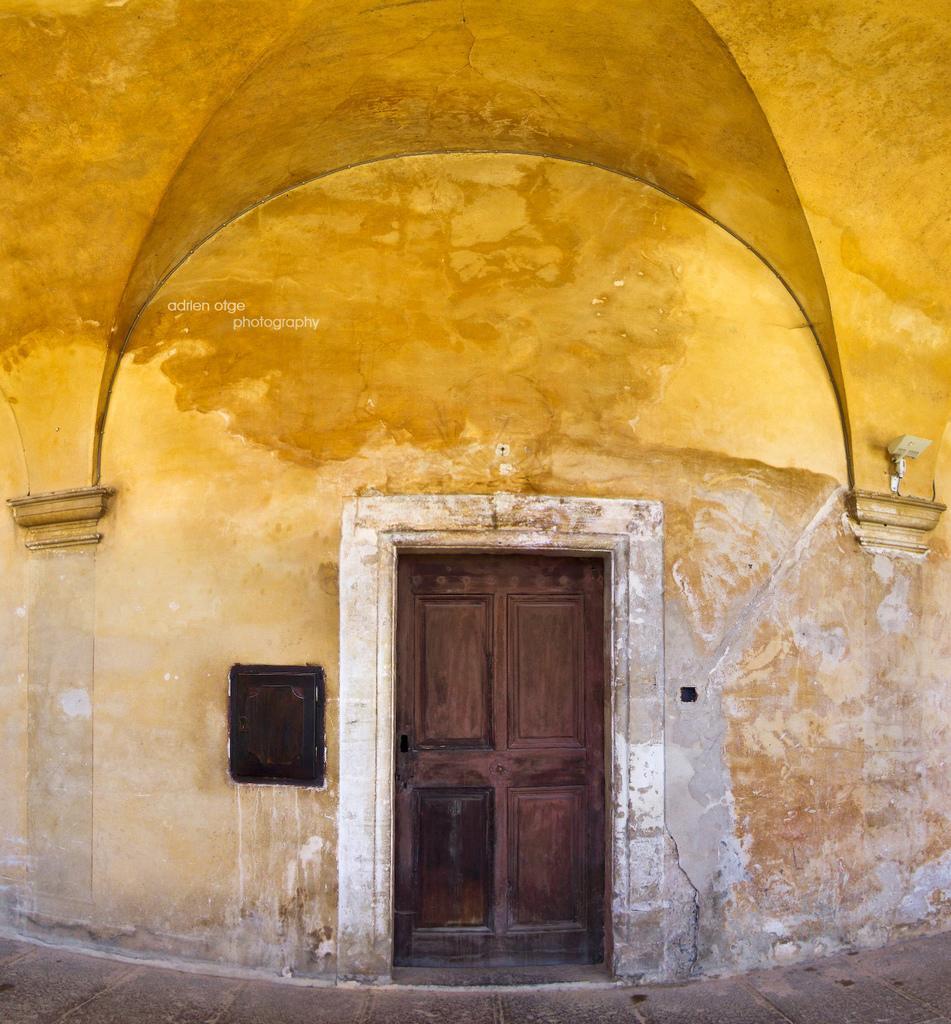Describe this image in one or two sentences. In this picture we can see a building. On this building, we can see a black and white object. We can see some text on the building. 